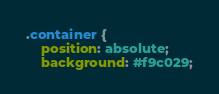<code> <loc_0><loc_0><loc_500><loc_500><_CSS_>
.container {
    position: absolute;
    background: #f9c029;</code> 